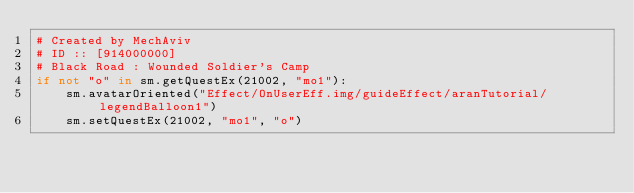Convert code to text. <code><loc_0><loc_0><loc_500><loc_500><_Python_># Created by MechAviv
# ID :: [914000000]
# Black Road : Wounded Soldier's Camp
if not "o" in sm.getQuestEx(21002, "mo1"):
    sm.avatarOriented("Effect/OnUserEff.img/guideEffect/aranTutorial/legendBalloon1")
    sm.setQuestEx(21002, "mo1", "o")</code> 